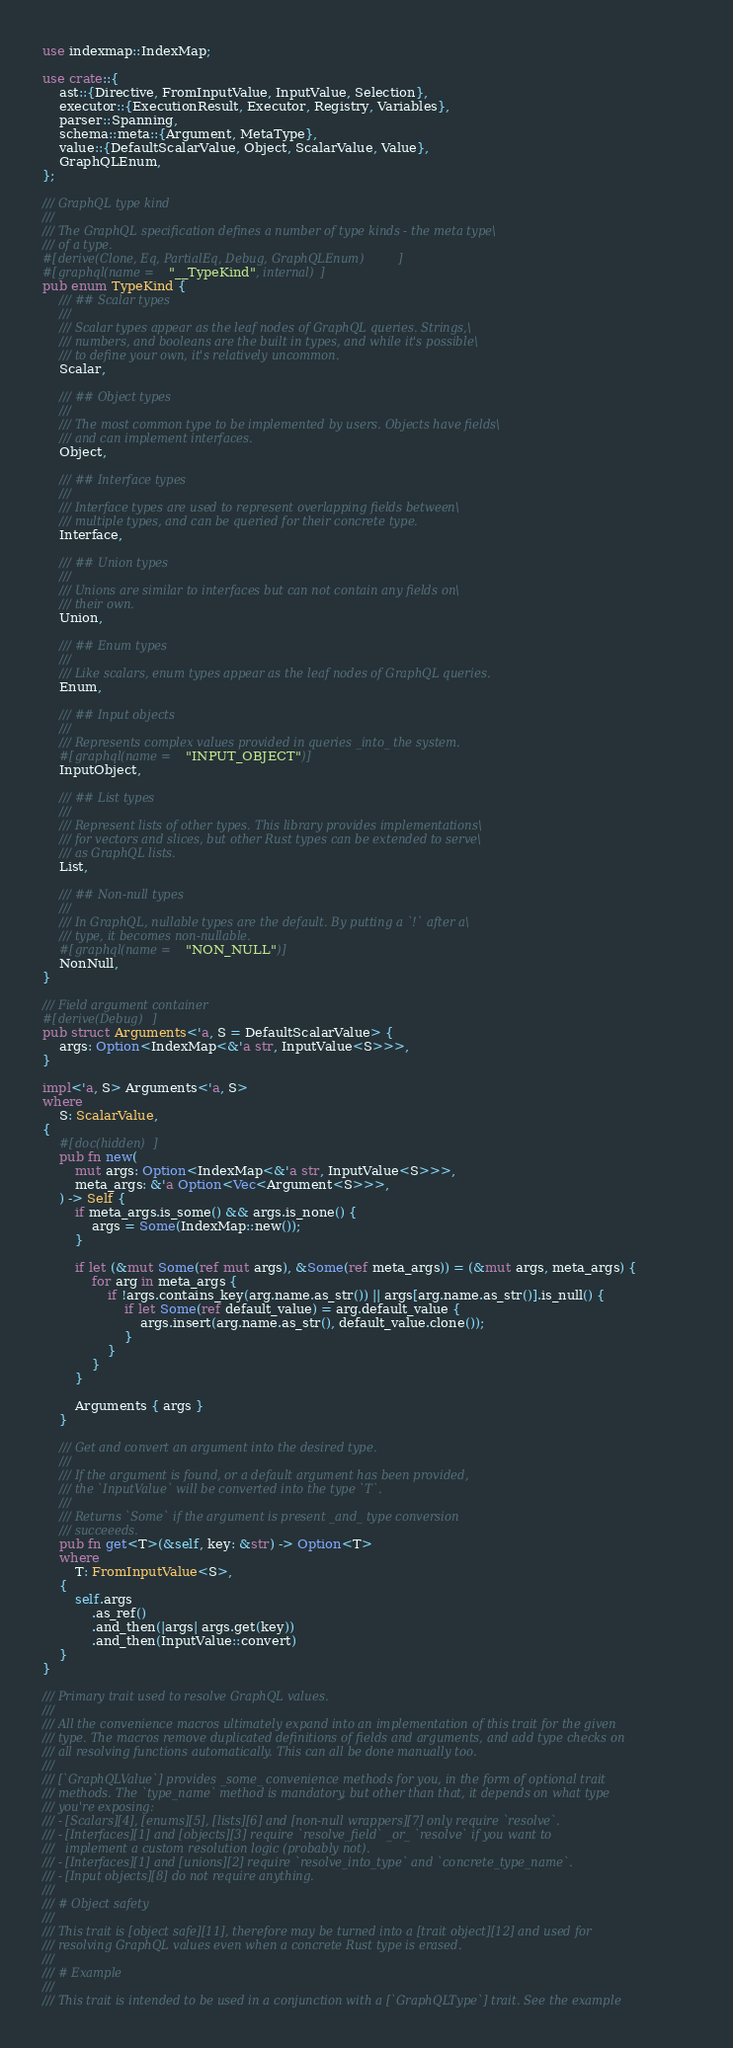<code> <loc_0><loc_0><loc_500><loc_500><_Rust_>use indexmap::IndexMap;

use crate::{
    ast::{Directive, FromInputValue, InputValue, Selection},
    executor::{ExecutionResult, Executor, Registry, Variables},
    parser::Spanning,
    schema::meta::{Argument, MetaType},
    value::{DefaultScalarValue, Object, ScalarValue, Value},
    GraphQLEnum,
};

/// GraphQL type kind
///
/// The GraphQL specification defines a number of type kinds - the meta type\
/// of a type.
#[derive(Clone, Eq, PartialEq, Debug, GraphQLEnum)]
#[graphql(name = "__TypeKind", internal)]
pub enum TypeKind {
    /// ## Scalar types
    ///
    /// Scalar types appear as the leaf nodes of GraphQL queries. Strings,\
    /// numbers, and booleans are the built in types, and while it's possible\
    /// to define your own, it's relatively uncommon.
    Scalar,

    /// ## Object types
    ///
    /// The most common type to be implemented by users. Objects have fields\
    /// and can implement interfaces.
    Object,

    /// ## Interface types
    ///
    /// Interface types are used to represent overlapping fields between\
    /// multiple types, and can be queried for their concrete type.
    Interface,

    /// ## Union types
    ///
    /// Unions are similar to interfaces but can not contain any fields on\
    /// their own.
    Union,

    /// ## Enum types
    ///
    /// Like scalars, enum types appear as the leaf nodes of GraphQL queries.
    Enum,

    /// ## Input objects
    ///
    /// Represents complex values provided in queries _into_ the system.
    #[graphql(name = "INPUT_OBJECT")]
    InputObject,

    /// ## List types
    ///
    /// Represent lists of other types. This library provides implementations\
    /// for vectors and slices, but other Rust types can be extended to serve\
    /// as GraphQL lists.
    List,

    /// ## Non-null types
    ///
    /// In GraphQL, nullable types are the default. By putting a `!` after a\
    /// type, it becomes non-nullable.
    #[graphql(name = "NON_NULL")]
    NonNull,
}

/// Field argument container
#[derive(Debug)]
pub struct Arguments<'a, S = DefaultScalarValue> {
    args: Option<IndexMap<&'a str, InputValue<S>>>,
}

impl<'a, S> Arguments<'a, S>
where
    S: ScalarValue,
{
    #[doc(hidden)]
    pub fn new(
        mut args: Option<IndexMap<&'a str, InputValue<S>>>,
        meta_args: &'a Option<Vec<Argument<S>>>,
    ) -> Self {
        if meta_args.is_some() && args.is_none() {
            args = Some(IndexMap::new());
        }

        if let (&mut Some(ref mut args), &Some(ref meta_args)) = (&mut args, meta_args) {
            for arg in meta_args {
                if !args.contains_key(arg.name.as_str()) || args[arg.name.as_str()].is_null() {
                    if let Some(ref default_value) = arg.default_value {
                        args.insert(arg.name.as_str(), default_value.clone());
                    }
                }
            }
        }

        Arguments { args }
    }

    /// Get and convert an argument into the desired type.
    ///
    /// If the argument is found, or a default argument has been provided,
    /// the `InputValue` will be converted into the type `T`.
    ///
    /// Returns `Some` if the argument is present _and_ type conversion
    /// succeeeds.
    pub fn get<T>(&self, key: &str) -> Option<T>
    where
        T: FromInputValue<S>,
    {
        self.args
            .as_ref()
            .and_then(|args| args.get(key))
            .and_then(InputValue::convert)
    }
}

/// Primary trait used to resolve GraphQL values.
///
/// All the convenience macros ultimately expand into an implementation of this trait for the given
/// type. The macros remove duplicated definitions of fields and arguments, and add type checks on
/// all resolving functions automatically. This can all be done manually too.
///
/// [`GraphQLValue`] provides _some_ convenience methods for you, in the form of optional trait
/// methods. The `type_name` method is mandatory, but other than that, it depends on what type
/// you're exposing:
/// - [Scalars][4], [enums][5], [lists][6] and [non-null wrappers][7] only require `resolve`.
/// - [Interfaces][1] and [objects][3] require `resolve_field` _or_ `resolve` if you want to
///   implement a custom resolution logic (probably not).
/// - [Interfaces][1] and [unions][2] require `resolve_into_type` and `concrete_type_name`.
/// - [Input objects][8] do not require anything.
///
/// # Object safety
///
/// This trait is [object safe][11], therefore may be turned into a [trait object][12] and used for
/// resolving GraphQL values even when a concrete Rust type is erased.
///
/// # Example
///
/// This trait is intended to be used in a conjunction with a [`GraphQLType`] trait. See the example</code> 